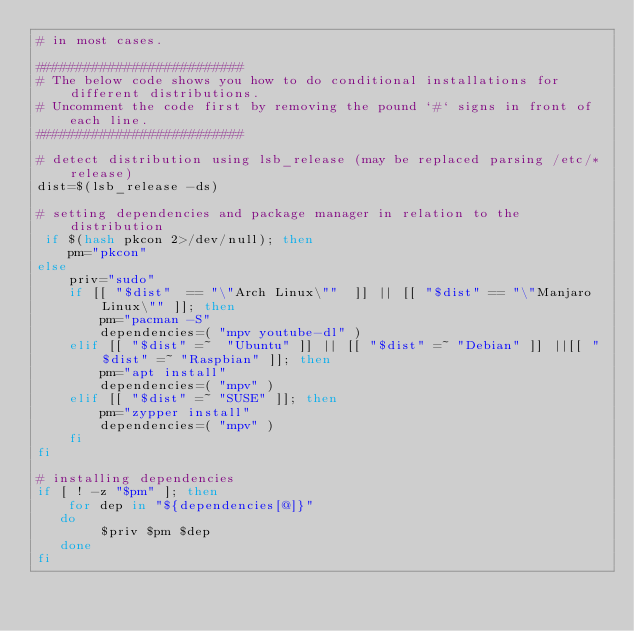Convert code to text. <code><loc_0><loc_0><loc_500><loc_500><_Bash_># in most cases. 

##########################
# The below code shows you how to do conditional installations for different distributions. 
# Uncomment the code first by removing the pound `#` signs in front of each line. 
##########################

# detect distribution using lsb_release (may be replaced parsing /etc/*release)
dist=$(lsb_release -ds)

# setting dependencies and package manager in relation to the distribution
 if $(hash pkcon 2>/dev/null); then
    pm="pkcon"
else
    priv="sudo"
    if [[ "$dist"  == "\"Arch Linux\""  ]] || [[ "$dist" == "\"Manjaro Linux\"" ]]; then
        pm="pacman -S"
        dependencies=( "mpv youtube-dl" )
    elif [[ "$dist" =~  "Ubuntu" ]] || [[ "$dist" =~ "Debian" ]] ||[[ "$dist" =~ "Raspbian" ]]; then
        pm="apt install"
        dependencies=( "mpv" )
    elif [[ "$dist" =~ "SUSE" ]]; then 
        pm="zypper install"
        dependencies=( "mpv" )
    fi
fi

# installing dependencies
if [ ! -z "$pm" ]; then
    for dep in "${dependencies[@]}"
   do
        $priv $pm $dep
   done
fi
</code> 